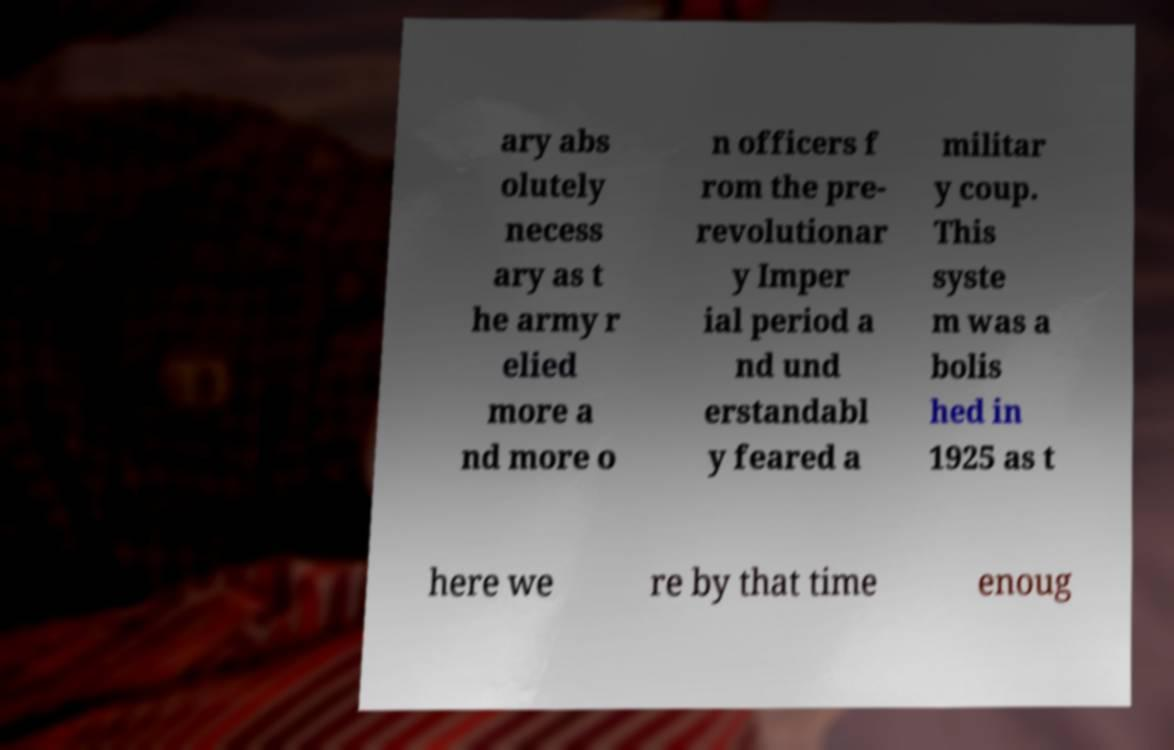There's text embedded in this image that I need extracted. Can you transcribe it verbatim? ary abs olutely necess ary as t he army r elied more a nd more o n officers f rom the pre- revolutionar y Imper ial period a nd und erstandabl y feared a militar y coup. This syste m was a bolis hed in 1925 as t here we re by that time enoug 